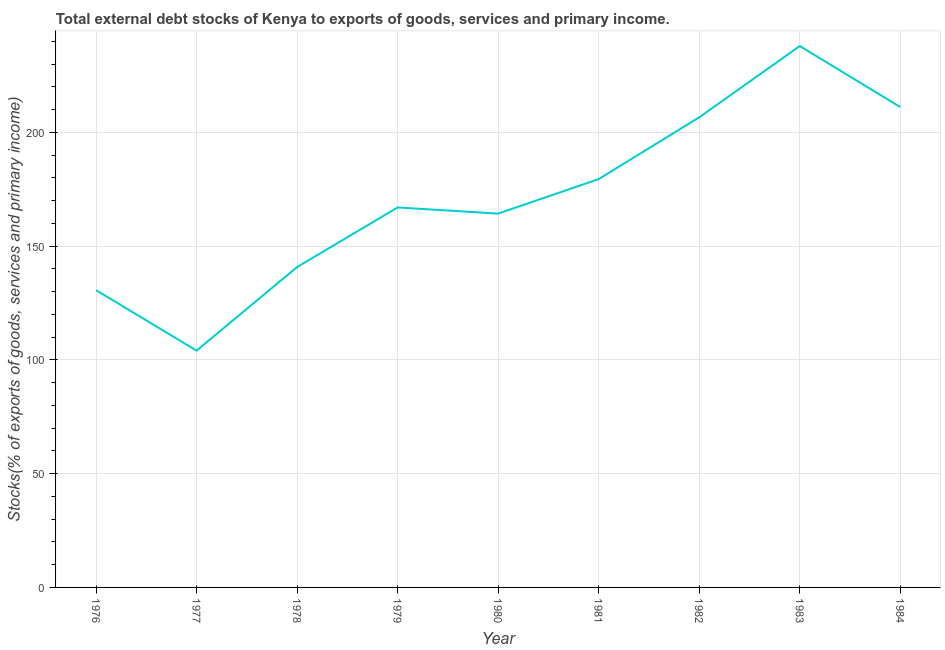What is the external debt stocks in 1978?
Make the answer very short. 140.82. Across all years, what is the maximum external debt stocks?
Offer a very short reply. 237.94. Across all years, what is the minimum external debt stocks?
Make the answer very short. 104.08. In which year was the external debt stocks maximum?
Your answer should be compact. 1983. In which year was the external debt stocks minimum?
Offer a terse response. 1977. What is the sum of the external debt stocks?
Your response must be concise. 1542.05. What is the difference between the external debt stocks in 1978 and 1984?
Ensure brevity in your answer.  -70.32. What is the average external debt stocks per year?
Offer a terse response. 171.34. What is the median external debt stocks?
Provide a succinct answer. 167. Do a majority of the years between 1984 and 1976 (inclusive) have external debt stocks greater than 80 %?
Offer a terse response. Yes. What is the ratio of the external debt stocks in 1978 to that in 1984?
Provide a short and direct response. 0.67. Is the difference between the external debt stocks in 1977 and 1984 greater than the difference between any two years?
Your answer should be compact. No. What is the difference between the highest and the second highest external debt stocks?
Your response must be concise. 26.8. Is the sum of the external debt stocks in 1979 and 1980 greater than the maximum external debt stocks across all years?
Provide a short and direct response. Yes. What is the difference between the highest and the lowest external debt stocks?
Your response must be concise. 133.87. In how many years, is the external debt stocks greater than the average external debt stocks taken over all years?
Give a very brief answer. 4. Does the external debt stocks monotonically increase over the years?
Your answer should be compact. No. How many lines are there?
Keep it short and to the point. 1. How many years are there in the graph?
Provide a succinct answer. 9. What is the difference between two consecutive major ticks on the Y-axis?
Offer a terse response. 50. Are the values on the major ticks of Y-axis written in scientific E-notation?
Ensure brevity in your answer.  No. Does the graph contain any zero values?
Keep it short and to the point. No. Does the graph contain grids?
Ensure brevity in your answer.  Yes. What is the title of the graph?
Provide a short and direct response. Total external debt stocks of Kenya to exports of goods, services and primary income. What is the label or title of the X-axis?
Your answer should be very brief. Year. What is the label or title of the Y-axis?
Keep it short and to the point. Stocks(% of exports of goods, services and primary income). What is the Stocks(% of exports of goods, services and primary income) of 1976?
Provide a succinct answer. 130.66. What is the Stocks(% of exports of goods, services and primary income) in 1977?
Offer a very short reply. 104.08. What is the Stocks(% of exports of goods, services and primary income) in 1978?
Give a very brief answer. 140.82. What is the Stocks(% of exports of goods, services and primary income) of 1979?
Provide a succinct answer. 167. What is the Stocks(% of exports of goods, services and primary income) in 1980?
Keep it short and to the point. 164.31. What is the Stocks(% of exports of goods, services and primary income) of 1981?
Keep it short and to the point. 179.48. What is the Stocks(% of exports of goods, services and primary income) of 1982?
Give a very brief answer. 206.62. What is the Stocks(% of exports of goods, services and primary income) of 1983?
Your answer should be compact. 237.94. What is the Stocks(% of exports of goods, services and primary income) in 1984?
Offer a very short reply. 211.14. What is the difference between the Stocks(% of exports of goods, services and primary income) in 1976 and 1977?
Give a very brief answer. 26.58. What is the difference between the Stocks(% of exports of goods, services and primary income) in 1976 and 1978?
Provide a short and direct response. -10.16. What is the difference between the Stocks(% of exports of goods, services and primary income) in 1976 and 1979?
Provide a succinct answer. -36.34. What is the difference between the Stocks(% of exports of goods, services and primary income) in 1976 and 1980?
Make the answer very short. -33.65. What is the difference between the Stocks(% of exports of goods, services and primary income) in 1976 and 1981?
Offer a very short reply. -48.82. What is the difference between the Stocks(% of exports of goods, services and primary income) in 1976 and 1982?
Make the answer very short. -75.96. What is the difference between the Stocks(% of exports of goods, services and primary income) in 1976 and 1983?
Provide a succinct answer. -107.29. What is the difference between the Stocks(% of exports of goods, services and primary income) in 1976 and 1984?
Your response must be concise. -80.48. What is the difference between the Stocks(% of exports of goods, services and primary income) in 1977 and 1978?
Provide a succinct answer. -36.75. What is the difference between the Stocks(% of exports of goods, services and primary income) in 1977 and 1979?
Ensure brevity in your answer.  -62.92. What is the difference between the Stocks(% of exports of goods, services and primary income) in 1977 and 1980?
Provide a succinct answer. -60.23. What is the difference between the Stocks(% of exports of goods, services and primary income) in 1977 and 1981?
Your answer should be compact. -75.4. What is the difference between the Stocks(% of exports of goods, services and primary income) in 1977 and 1982?
Your answer should be very brief. -102.54. What is the difference between the Stocks(% of exports of goods, services and primary income) in 1977 and 1983?
Make the answer very short. -133.87. What is the difference between the Stocks(% of exports of goods, services and primary income) in 1977 and 1984?
Provide a succinct answer. -107.06. What is the difference between the Stocks(% of exports of goods, services and primary income) in 1978 and 1979?
Give a very brief answer. -26.17. What is the difference between the Stocks(% of exports of goods, services and primary income) in 1978 and 1980?
Provide a short and direct response. -23.48. What is the difference between the Stocks(% of exports of goods, services and primary income) in 1978 and 1981?
Keep it short and to the point. -38.66. What is the difference between the Stocks(% of exports of goods, services and primary income) in 1978 and 1982?
Give a very brief answer. -65.8. What is the difference between the Stocks(% of exports of goods, services and primary income) in 1978 and 1983?
Your answer should be compact. -97.12. What is the difference between the Stocks(% of exports of goods, services and primary income) in 1978 and 1984?
Make the answer very short. -70.32. What is the difference between the Stocks(% of exports of goods, services and primary income) in 1979 and 1980?
Your answer should be very brief. 2.69. What is the difference between the Stocks(% of exports of goods, services and primary income) in 1979 and 1981?
Ensure brevity in your answer.  -12.48. What is the difference between the Stocks(% of exports of goods, services and primary income) in 1979 and 1982?
Your answer should be very brief. -39.62. What is the difference between the Stocks(% of exports of goods, services and primary income) in 1979 and 1983?
Offer a very short reply. -70.95. What is the difference between the Stocks(% of exports of goods, services and primary income) in 1979 and 1984?
Offer a very short reply. -44.14. What is the difference between the Stocks(% of exports of goods, services and primary income) in 1980 and 1981?
Ensure brevity in your answer.  -15.17. What is the difference between the Stocks(% of exports of goods, services and primary income) in 1980 and 1982?
Offer a very short reply. -42.31. What is the difference between the Stocks(% of exports of goods, services and primary income) in 1980 and 1983?
Your response must be concise. -73.64. What is the difference between the Stocks(% of exports of goods, services and primary income) in 1980 and 1984?
Keep it short and to the point. -46.83. What is the difference between the Stocks(% of exports of goods, services and primary income) in 1981 and 1982?
Your answer should be very brief. -27.14. What is the difference between the Stocks(% of exports of goods, services and primary income) in 1981 and 1983?
Ensure brevity in your answer.  -58.46. What is the difference between the Stocks(% of exports of goods, services and primary income) in 1981 and 1984?
Make the answer very short. -31.66. What is the difference between the Stocks(% of exports of goods, services and primary income) in 1982 and 1983?
Provide a short and direct response. -31.32. What is the difference between the Stocks(% of exports of goods, services and primary income) in 1982 and 1984?
Make the answer very short. -4.52. What is the difference between the Stocks(% of exports of goods, services and primary income) in 1983 and 1984?
Offer a terse response. 26.8. What is the ratio of the Stocks(% of exports of goods, services and primary income) in 1976 to that in 1977?
Make the answer very short. 1.25. What is the ratio of the Stocks(% of exports of goods, services and primary income) in 1976 to that in 1978?
Offer a very short reply. 0.93. What is the ratio of the Stocks(% of exports of goods, services and primary income) in 1976 to that in 1979?
Give a very brief answer. 0.78. What is the ratio of the Stocks(% of exports of goods, services and primary income) in 1976 to that in 1980?
Offer a very short reply. 0.8. What is the ratio of the Stocks(% of exports of goods, services and primary income) in 1976 to that in 1981?
Keep it short and to the point. 0.73. What is the ratio of the Stocks(% of exports of goods, services and primary income) in 1976 to that in 1982?
Your response must be concise. 0.63. What is the ratio of the Stocks(% of exports of goods, services and primary income) in 1976 to that in 1983?
Provide a succinct answer. 0.55. What is the ratio of the Stocks(% of exports of goods, services and primary income) in 1976 to that in 1984?
Keep it short and to the point. 0.62. What is the ratio of the Stocks(% of exports of goods, services and primary income) in 1977 to that in 1978?
Ensure brevity in your answer.  0.74. What is the ratio of the Stocks(% of exports of goods, services and primary income) in 1977 to that in 1979?
Give a very brief answer. 0.62. What is the ratio of the Stocks(% of exports of goods, services and primary income) in 1977 to that in 1980?
Your response must be concise. 0.63. What is the ratio of the Stocks(% of exports of goods, services and primary income) in 1977 to that in 1981?
Ensure brevity in your answer.  0.58. What is the ratio of the Stocks(% of exports of goods, services and primary income) in 1977 to that in 1982?
Give a very brief answer. 0.5. What is the ratio of the Stocks(% of exports of goods, services and primary income) in 1977 to that in 1983?
Keep it short and to the point. 0.44. What is the ratio of the Stocks(% of exports of goods, services and primary income) in 1977 to that in 1984?
Offer a terse response. 0.49. What is the ratio of the Stocks(% of exports of goods, services and primary income) in 1978 to that in 1979?
Offer a terse response. 0.84. What is the ratio of the Stocks(% of exports of goods, services and primary income) in 1978 to that in 1980?
Offer a very short reply. 0.86. What is the ratio of the Stocks(% of exports of goods, services and primary income) in 1978 to that in 1981?
Offer a terse response. 0.79. What is the ratio of the Stocks(% of exports of goods, services and primary income) in 1978 to that in 1982?
Give a very brief answer. 0.68. What is the ratio of the Stocks(% of exports of goods, services and primary income) in 1978 to that in 1983?
Your answer should be very brief. 0.59. What is the ratio of the Stocks(% of exports of goods, services and primary income) in 1978 to that in 1984?
Ensure brevity in your answer.  0.67. What is the ratio of the Stocks(% of exports of goods, services and primary income) in 1979 to that in 1980?
Provide a succinct answer. 1.02. What is the ratio of the Stocks(% of exports of goods, services and primary income) in 1979 to that in 1981?
Offer a terse response. 0.93. What is the ratio of the Stocks(% of exports of goods, services and primary income) in 1979 to that in 1982?
Provide a succinct answer. 0.81. What is the ratio of the Stocks(% of exports of goods, services and primary income) in 1979 to that in 1983?
Your answer should be compact. 0.7. What is the ratio of the Stocks(% of exports of goods, services and primary income) in 1979 to that in 1984?
Provide a succinct answer. 0.79. What is the ratio of the Stocks(% of exports of goods, services and primary income) in 1980 to that in 1981?
Your answer should be very brief. 0.92. What is the ratio of the Stocks(% of exports of goods, services and primary income) in 1980 to that in 1982?
Your response must be concise. 0.8. What is the ratio of the Stocks(% of exports of goods, services and primary income) in 1980 to that in 1983?
Offer a very short reply. 0.69. What is the ratio of the Stocks(% of exports of goods, services and primary income) in 1980 to that in 1984?
Give a very brief answer. 0.78. What is the ratio of the Stocks(% of exports of goods, services and primary income) in 1981 to that in 1982?
Offer a terse response. 0.87. What is the ratio of the Stocks(% of exports of goods, services and primary income) in 1981 to that in 1983?
Your answer should be very brief. 0.75. What is the ratio of the Stocks(% of exports of goods, services and primary income) in 1981 to that in 1984?
Your response must be concise. 0.85. What is the ratio of the Stocks(% of exports of goods, services and primary income) in 1982 to that in 1983?
Give a very brief answer. 0.87. What is the ratio of the Stocks(% of exports of goods, services and primary income) in 1983 to that in 1984?
Make the answer very short. 1.13. 